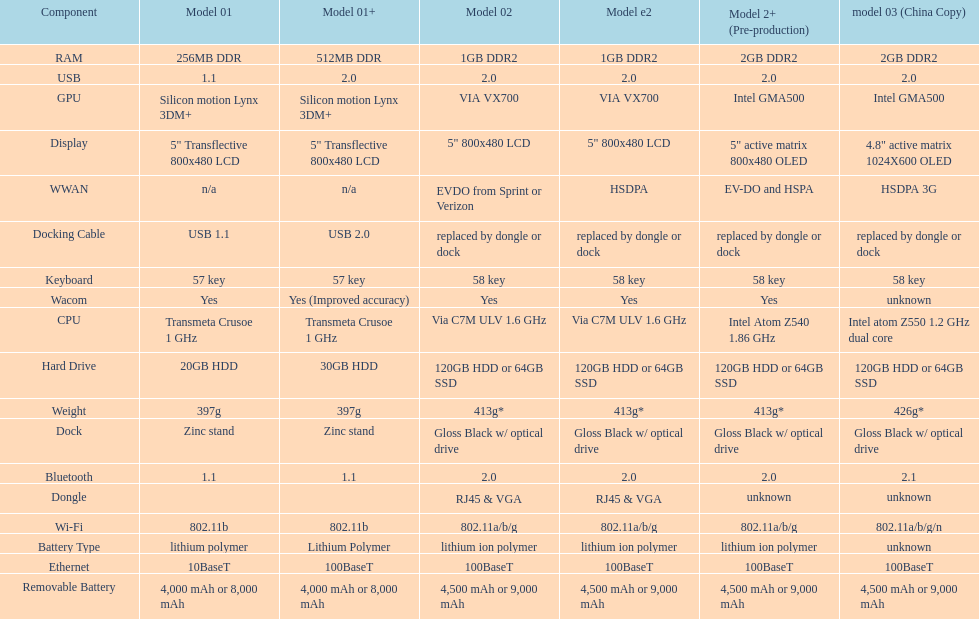How much more weight does the model 3 have over model 1? 29g. Would you be able to parse every entry in this table? {'header': ['Component', 'Model 01', 'Model 01+', 'Model 02', 'Model e2', 'Model 2+ (Pre-production)', 'model 03 (China Copy)'], 'rows': [['RAM', '256MB DDR', '512MB DDR', '1GB DDR2', '1GB DDR2', '2GB DDR2', '2GB DDR2'], ['USB', '1.1', '2.0', '2.0', '2.0', '2.0', '2.0'], ['GPU', 'Silicon motion Lynx 3DM+', 'Silicon motion Lynx 3DM+', 'VIA VX700', 'VIA VX700', 'Intel GMA500', 'Intel GMA500'], ['Display', '5" Transflective 800x480 LCD', '5" Transflective 800x480 LCD', '5" 800x480 LCD', '5" 800x480 LCD', '5" active matrix 800x480 OLED', '4.8" active matrix 1024X600 OLED'], ['WWAN', 'n/a', 'n/a', 'EVDO from Sprint or Verizon', 'HSDPA', 'EV-DO and HSPA', 'HSDPA 3G'], ['Docking Cable', 'USB 1.1', 'USB 2.0', 'replaced by dongle or dock', 'replaced by dongle or dock', 'replaced by dongle or dock', 'replaced by dongle or dock'], ['Keyboard', '57 key', '57 key', '58 key', '58 key', '58 key', '58 key'], ['Wacom', 'Yes', 'Yes (Improved accuracy)', 'Yes', 'Yes', 'Yes', 'unknown'], ['CPU', 'Transmeta Crusoe 1\xa0GHz', 'Transmeta Crusoe 1\xa0GHz', 'Via C7M ULV 1.6\xa0GHz', 'Via C7M ULV 1.6\xa0GHz', 'Intel Atom Z540 1.86\xa0GHz', 'Intel atom Z550 1.2\xa0GHz dual core'], ['Hard Drive', '20GB HDD', '30GB HDD', '120GB HDD or 64GB SSD', '120GB HDD or 64GB SSD', '120GB HDD or 64GB SSD', '120GB HDD or 64GB SSD'], ['Weight', '397g', '397g', '413g*', '413g*', '413g*', '426g*'], ['Dock', 'Zinc stand', 'Zinc stand', 'Gloss Black w/ optical drive', 'Gloss Black w/ optical drive', 'Gloss Black w/ optical drive', 'Gloss Black w/ optical drive'], ['Bluetooth', '1.1', '1.1', '2.0', '2.0', '2.0', '2.1'], ['Dongle', '', '', 'RJ45 & VGA', 'RJ45 & VGA', 'unknown', 'unknown'], ['Wi-Fi', '802.11b', '802.11b', '802.11a/b/g', '802.11a/b/g', '802.11a/b/g', '802.11a/b/g/n'], ['Battery Type', 'lithium polymer', 'Lithium Polymer', 'lithium ion polymer', 'lithium ion polymer', 'lithium ion polymer', 'unknown'], ['Ethernet', '10BaseT', '100BaseT', '100BaseT', '100BaseT', '100BaseT', '100BaseT'], ['Removable Battery', '4,000 mAh or 8,000 mAh', '4,000 mAh or 8,000 mAh', '4,500 mAh or 9,000 mAh', '4,500 mAh or 9,000 mAh', '4,500 mAh or 9,000 mAh', '4,500 mAh or 9,000 mAh']]} 